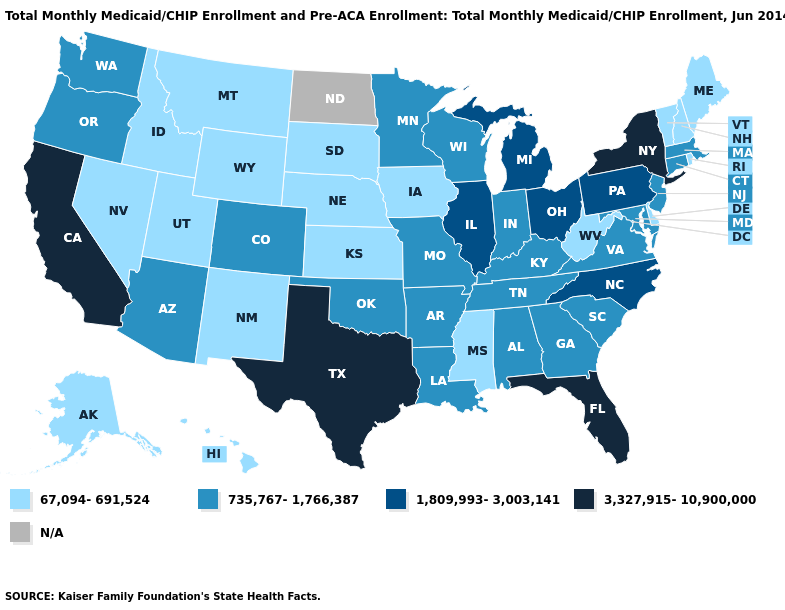Does the map have missing data?
Answer briefly. Yes. Name the states that have a value in the range 67,094-691,524?
Concise answer only. Alaska, Delaware, Hawaii, Idaho, Iowa, Kansas, Maine, Mississippi, Montana, Nebraska, Nevada, New Hampshire, New Mexico, Rhode Island, South Dakota, Utah, Vermont, West Virginia, Wyoming. What is the highest value in the USA?
Quick response, please. 3,327,915-10,900,000. Which states have the lowest value in the USA?
Concise answer only. Alaska, Delaware, Hawaii, Idaho, Iowa, Kansas, Maine, Mississippi, Montana, Nebraska, Nevada, New Hampshire, New Mexico, Rhode Island, South Dakota, Utah, Vermont, West Virginia, Wyoming. Which states have the highest value in the USA?
Answer briefly. California, Florida, New York, Texas. Name the states that have a value in the range 3,327,915-10,900,000?
Quick response, please. California, Florida, New York, Texas. What is the value of West Virginia?
Keep it brief. 67,094-691,524. Name the states that have a value in the range N/A?
Answer briefly. North Dakota. Is the legend a continuous bar?
Concise answer only. No. What is the value of Oklahoma?
Keep it brief. 735,767-1,766,387. Name the states that have a value in the range 3,327,915-10,900,000?
Be succinct. California, Florida, New York, Texas. What is the lowest value in states that border New York?
Be succinct. 67,094-691,524. What is the highest value in the USA?
Short answer required. 3,327,915-10,900,000. What is the lowest value in the MidWest?
Be succinct. 67,094-691,524. 